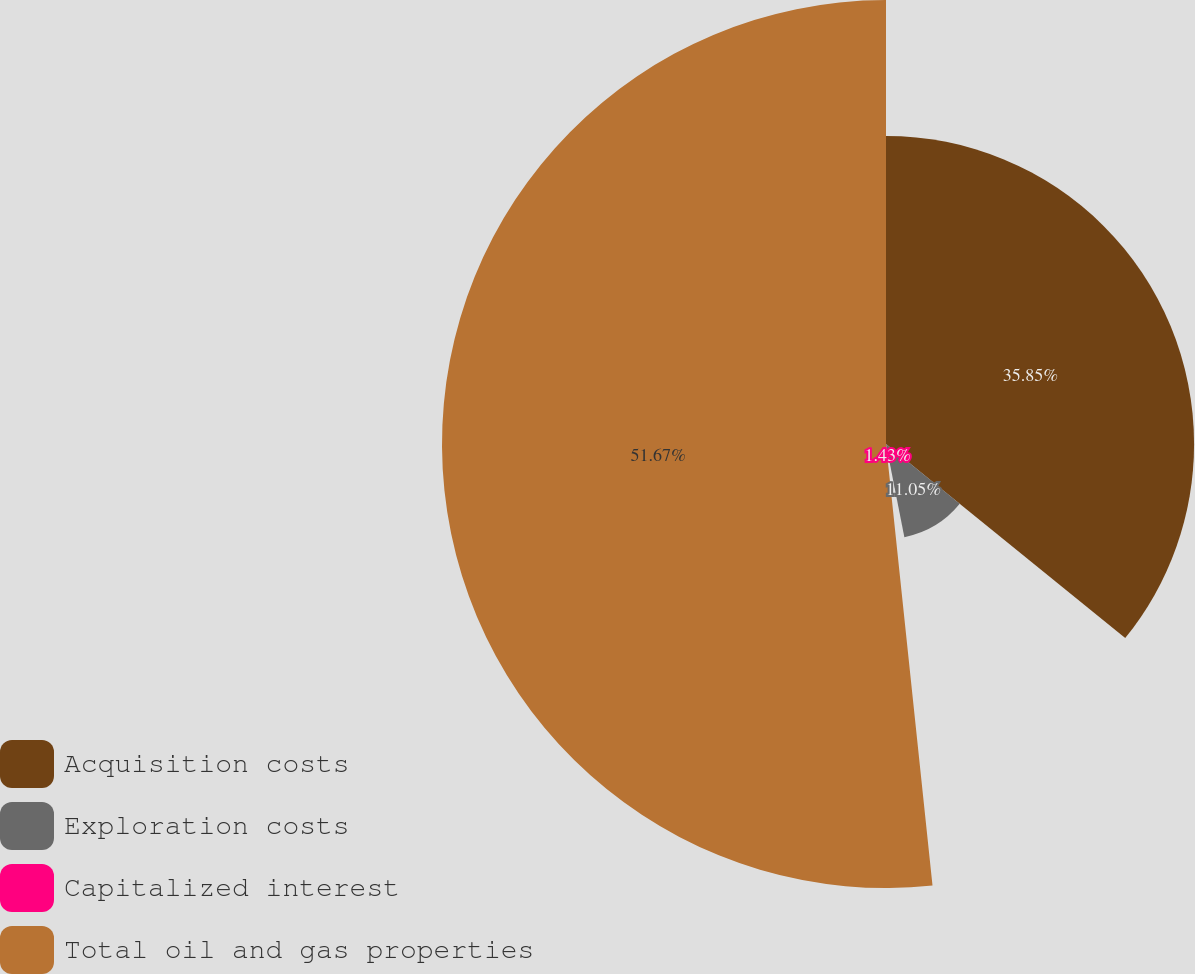Convert chart. <chart><loc_0><loc_0><loc_500><loc_500><pie_chart><fcel>Acquisition costs<fcel>Exploration costs<fcel>Capitalized interest<fcel>Total oil and gas properties<nl><fcel>35.85%<fcel>11.05%<fcel>1.43%<fcel>51.67%<nl></chart> 